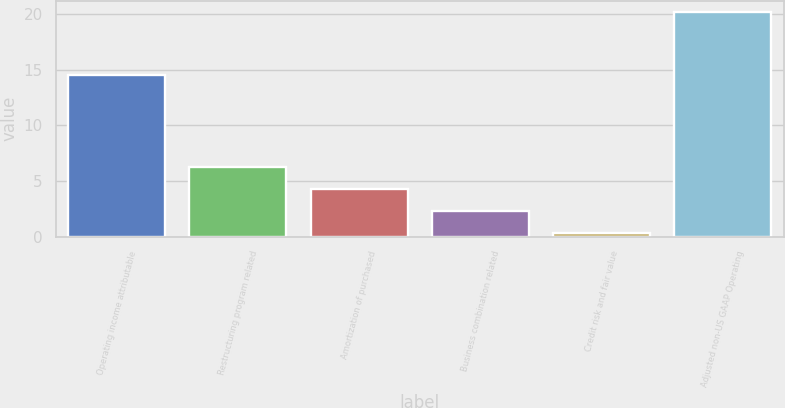<chart> <loc_0><loc_0><loc_500><loc_500><bar_chart><fcel>Operating income attributable<fcel>Restructuring program related<fcel>Amortization of purchased<fcel>Business combination related<fcel>Credit risk and fair value<fcel>Adjusted non-US GAAP Operating<nl><fcel>14.5<fcel>6.27<fcel>4.28<fcel>2.29<fcel>0.3<fcel>20.2<nl></chart> 